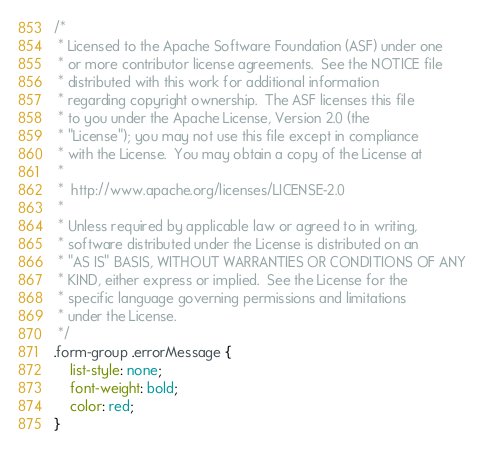Convert code to text. <code><loc_0><loc_0><loc_500><loc_500><_CSS_>/*
 * Licensed to the Apache Software Foundation (ASF) under one
 * or more contributor license agreements.  See the NOTICE file
 * distributed with this work for additional information
 * regarding copyright ownership.  The ASF licenses this file
 * to you under the Apache License, Version 2.0 (the
 * "License"); you may not use this file except in compliance
 * with the License.  You may obtain a copy of the License at
 *
 *  http://www.apache.org/licenses/LICENSE-2.0
 *
 * Unless required by applicable law or agreed to in writing,
 * software distributed under the License is distributed on an
 * "AS IS" BASIS, WITHOUT WARRANTIES OR CONDITIONS OF ANY
 * KIND, either express or implied.  See the License for the
 * specific language governing permissions and limitations
 * under the License.
 */
.form-group .errorMessage {
    list-style: none;
    font-weight: bold;
    color: red;
}</code> 